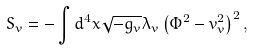Convert formula to latex. <formula><loc_0><loc_0><loc_500><loc_500>S _ { v } = - \int d ^ { 4 } x \sqrt { - g _ { v } } \lambda _ { v } \left ( \Phi ^ { 2 } - v _ { v } ^ { 2 } \right ) ^ { 2 } ,</formula> 